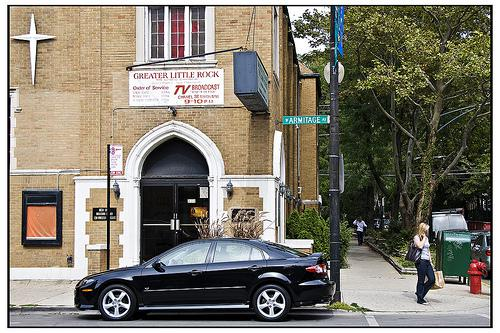Question: what is the name of this church?
Choices:
A. Little Rock Church.
B. Greater Little Rock.
C. Church of Little Rock.
D. New Baptist Church of Little Rock.
Answer with the letter. Answer: B Question: what street is the church on?
Choices:
A. Vine.
B. Broadway.
C. Pike.
D. Armitage.
Answer with the letter. Answer: D Question: what color is the car?
Choices:
A. Black.
B. White.
C. Red.
D. Blue.
Answer with the letter. Answer: A Question: how many bags are each of the people holding?
Choices:
A. Four.
B. Three.
C. One.
D. Two.
Answer with the letter. Answer: D 